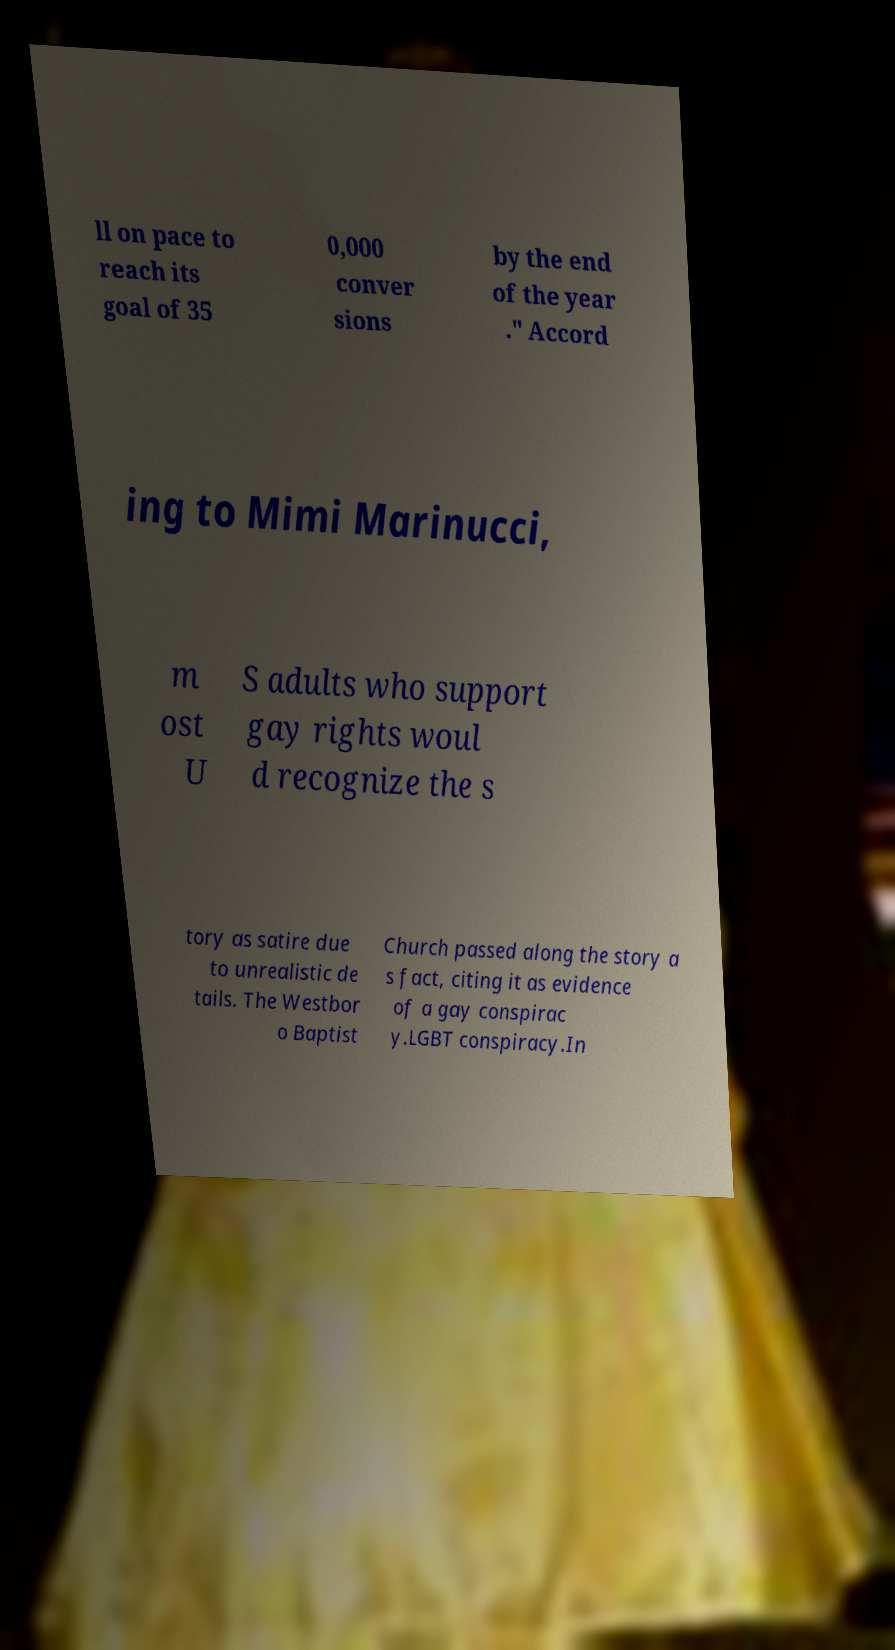Can you accurately transcribe the text from the provided image for me? ll on pace to reach its goal of 35 0,000 conver sions by the end of the year ." Accord ing to Mimi Marinucci, m ost U S adults who support gay rights woul d recognize the s tory as satire due to unrealistic de tails. The Westbor o Baptist Church passed along the story a s fact, citing it as evidence of a gay conspirac y.LGBT conspiracy.In 